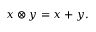<formula> <loc_0><loc_0><loc_500><loc_500>x \otimes y = x + y .</formula> 